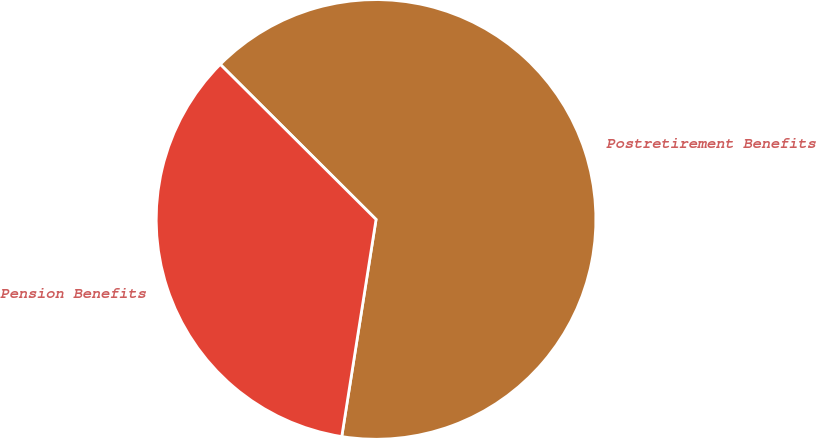Convert chart. <chart><loc_0><loc_0><loc_500><loc_500><pie_chart><fcel>Postretirement Benefits<fcel>Pension Benefits<nl><fcel>65.03%<fcel>34.97%<nl></chart> 